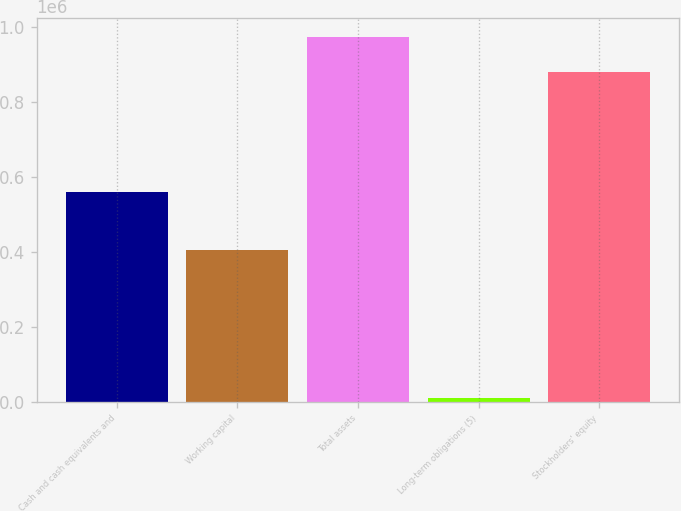Convert chart to OTSL. <chart><loc_0><loc_0><loc_500><loc_500><bar_chart><fcel>Cash and cash equivalents and<fcel>Working capital<fcel>Total assets<fcel>Long-term obligations (5)<fcel>Stockholders' equity<nl><fcel>559189<fcel>404836<fcel>972998<fcel>9969<fcel>877681<nl></chart> 